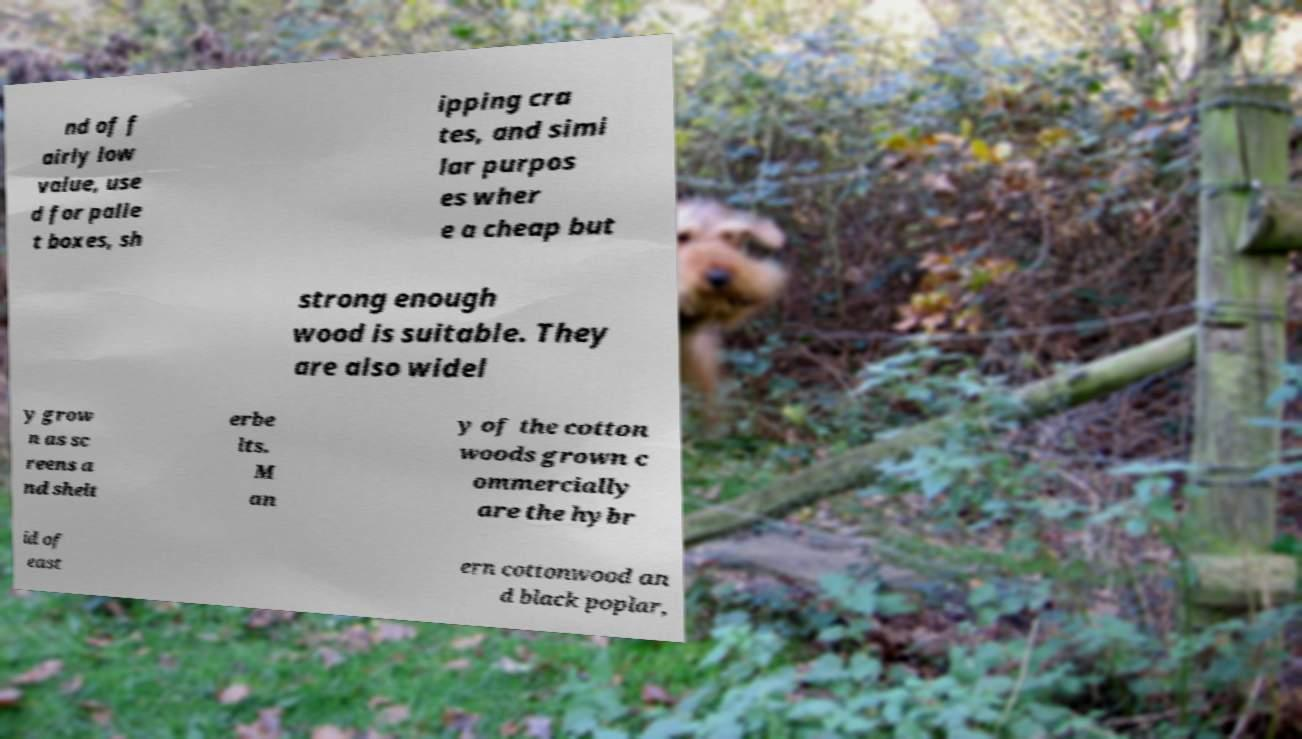Please read and relay the text visible in this image. What does it say? nd of f airly low value, use d for palle t boxes, sh ipping cra tes, and simi lar purpos es wher e a cheap but strong enough wood is suitable. They are also widel y grow n as sc reens a nd shelt erbe lts. M an y of the cotton woods grown c ommercially are the hybr id of east ern cottonwood an d black poplar, 